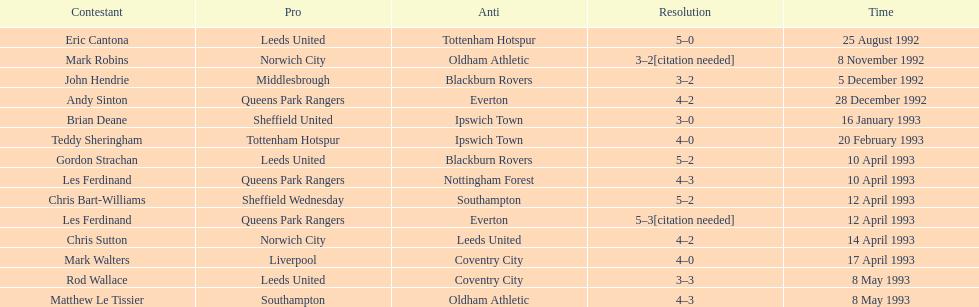Name the players for tottenham hotspur. Teddy Sheringham. 